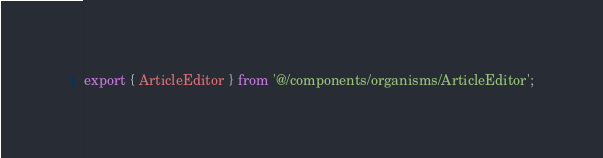Convert code to text. <code><loc_0><loc_0><loc_500><loc_500><_TypeScript_>export { ArticleEditor } from '@/components/organisms/ArticleEditor';
</code> 